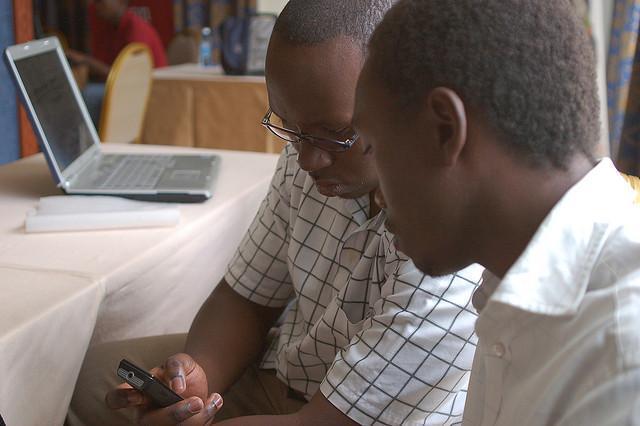How many phones do they have?
Give a very brief answer. 1. How many people are in the picture?
Give a very brief answer. 3. How many dining tables can you see?
Give a very brief answer. 2. How many chairs are in the photo?
Give a very brief answer. 1. 